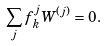<formula> <loc_0><loc_0><loc_500><loc_500>\sum _ { j } f _ { k } ^ { j } W ^ { ( j ) } = 0 .</formula> 